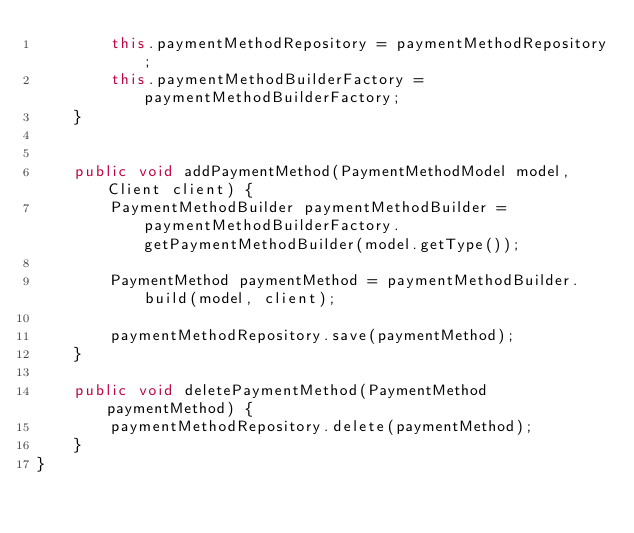Convert code to text. <code><loc_0><loc_0><loc_500><loc_500><_Java_>        this.paymentMethodRepository = paymentMethodRepository;
        this.paymentMethodBuilderFactory = paymentMethodBuilderFactory;
    }


    public void addPaymentMethod(PaymentMethodModel model, Client client) {
        PaymentMethodBuilder paymentMethodBuilder = paymentMethodBuilderFactory.getPaymentMethodBuilder(model.getType());

        PaymentMethod paymentMethod = paymentMethodBuilder.build(model, client);

        paymentMethodRepository.save(paymentMethod);
    }

    public void deletePaymentMethod(PaymentMethod paymentMethod) {
        paymentMethodRepository.delete(paymentMethod);
    }
}
</code> 